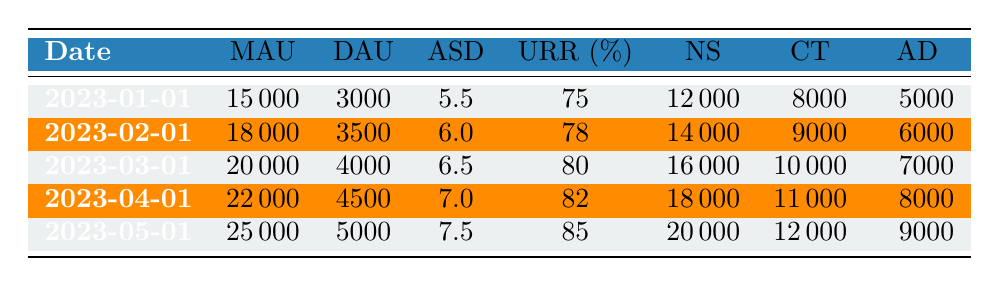What is the monthly active users on 2023-02-01? The table shows the number of monthly active users for each date. For 2023-02-01, the value listed under "MAU" is 18000.
Answer: 18000 What was the average session duration (ASD) in March? Looking at the table for the date 2023-03-01, the corresponding average session duration is 6.5.
Answer: 6.5 What is the difference in user retention rate (URR) between January and May? The user retention rates for January (75) and May (85) are shown in the table. The difference is calculated as 85 - 75 = 10.
Answer: 10 On which date did the daily active users (DAU) first exceed 4000? Checking the rows in the table, the first time the daily active users exceeds 4000 is on 2023-03-01 when the DAU is 4000.
Answer: 2023-03-01 Is the feature usage for analytics dashboard higher in April compared to February? The feature usage for analytics dashboard in April (8000) and February (6000) are listed. Since 8000 > 6000, the answer is yes.
Answer: Yes What was the total feature usage for the notification system across all five months? Adding the notification system usage for each month: 12000 (Jan) + 14000 (Feb) + 16000 (Mar) + 18000 (Apr) + 20000 (May) is calculated as 12000 + 14000 + 16000 + 18000 + 20000 = 100000.
Answer: 100000 What is the maximum daily active users recorded during the data range? Examining the DAU column, the maximum value is for May 2023, which shows 5000.
Answer: 5000 Did the average session duration increase every month from January to May? The average session durations listed are: 5.5 (Jan), 6.0 (Feb), 6.5 (Mar), 7.0 (Apr), and 7.5 (May). Since they all show an increasing trend, the answer is yes.
Answer: Yes What is the overall percentage increase in monthly active users from January to May? The monthly active users for January is 15000 and for May is 25000. The increase is calculated as (25000 - 15000) / 15000 * 100 = 66.67%.
Answer: 66.67% 